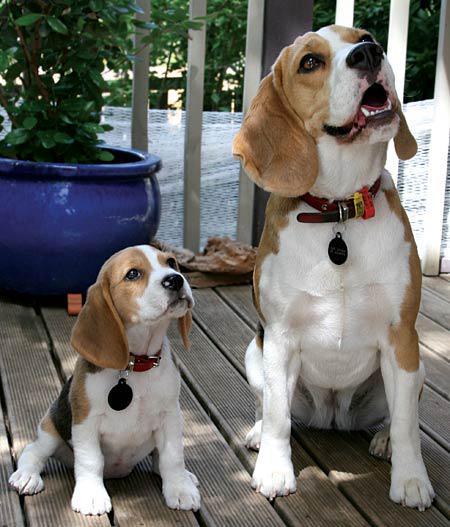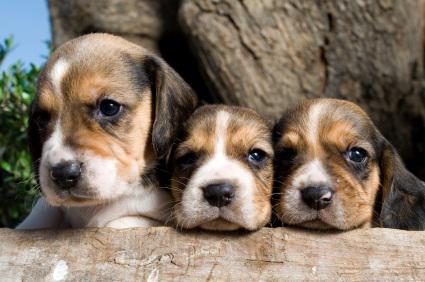The first image is the image on the left, the second image is the image on the right. Assess this claim about the two images: "One of the images has exactly two dogs.". Correct or not? Answer yes or no. Yes. The first image is the image on the left, the second image is the image on the right. Assess this claim about the two images: "There are at most five dogs.". Correct or not? Answer yes or no. Yes. 